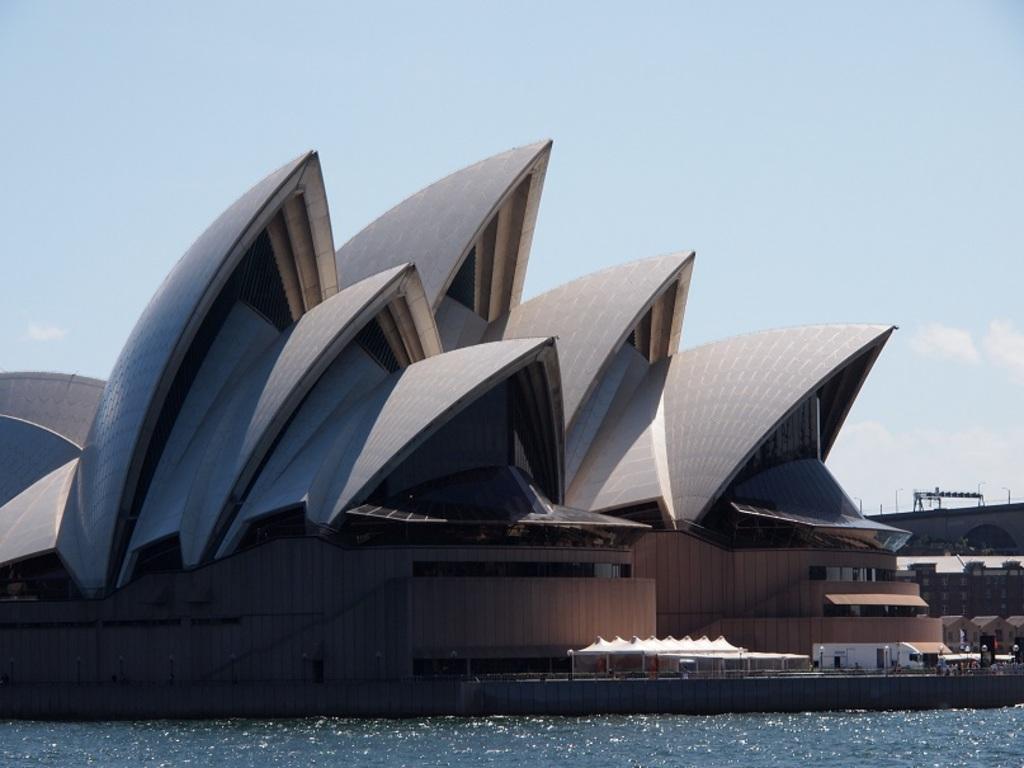How would you summarize this image in a sentence or two? This picture consists of building, in front of the building there is the lake and at the top I can see the sky. 